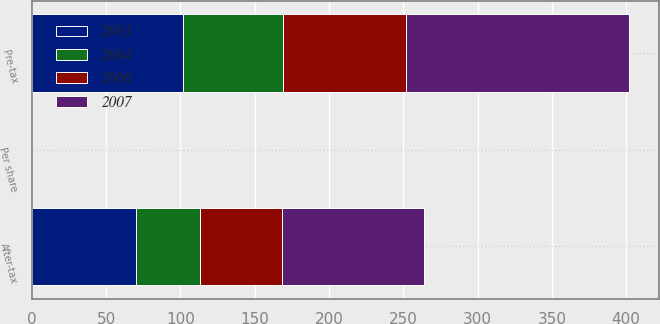<chart> <loc_0><loc_0><loc_500><loc_500><stacked_bar_chart><ecel><fcel>Pre-tax<fcel>After-tax<fcel>Per share<nl><fcel>2003<fcel>102<fcel>70<fcel>0.04<nl><fcel>2004<fcel>67<fcel>43<fcel>0.03<nl><fcel>2006<fcel>83<fcel>55<fcel>0.03<nl><fcel>2007<fcel>150<fcel>96<fcel>0.06<nl></chart> 